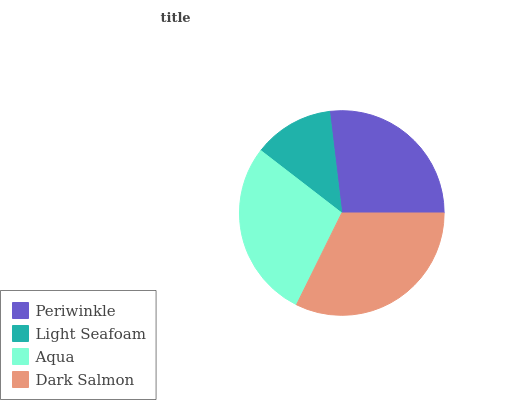Is Light Seafoam the minimum?
Answer yes or no. Yes. Is Dark Salmon the maximum?
Answer yes or no. Yes. Is Aqua the minimum?
Answer yes or no. No. Is Aqua the maximum?
Answer yes or no. No. Is Aqua greater than Light Seafoam?
Answer yes or no. Yes. Is Light Seafoam less than Aqua?
Answer yes or no. Yes. Is Light Seafoam greater than Aqua?
Answer yes or no. No. Is Aqua less than Light Seafoam?
Answer yes or no. No. Is Aqua the high median?
Answer yes or no. Yes. Is Periwinkle the low median?
Answer yes or no. Yes. Is Periwinkle the high median?
Answer yes or no. No. Is Light Seafoam the low median?
Answer yes or no. No. 